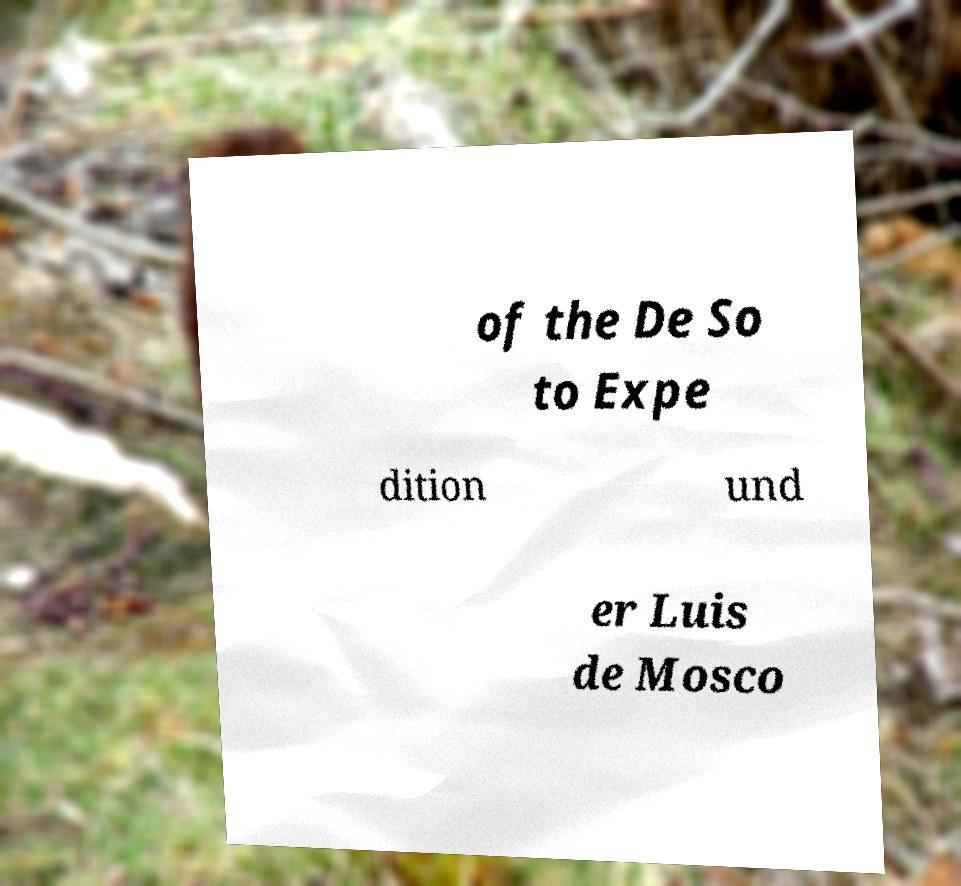I need the written content from this picture converted into text. Can you do that? of the De So to Expe dition und er Luis de Mosco 